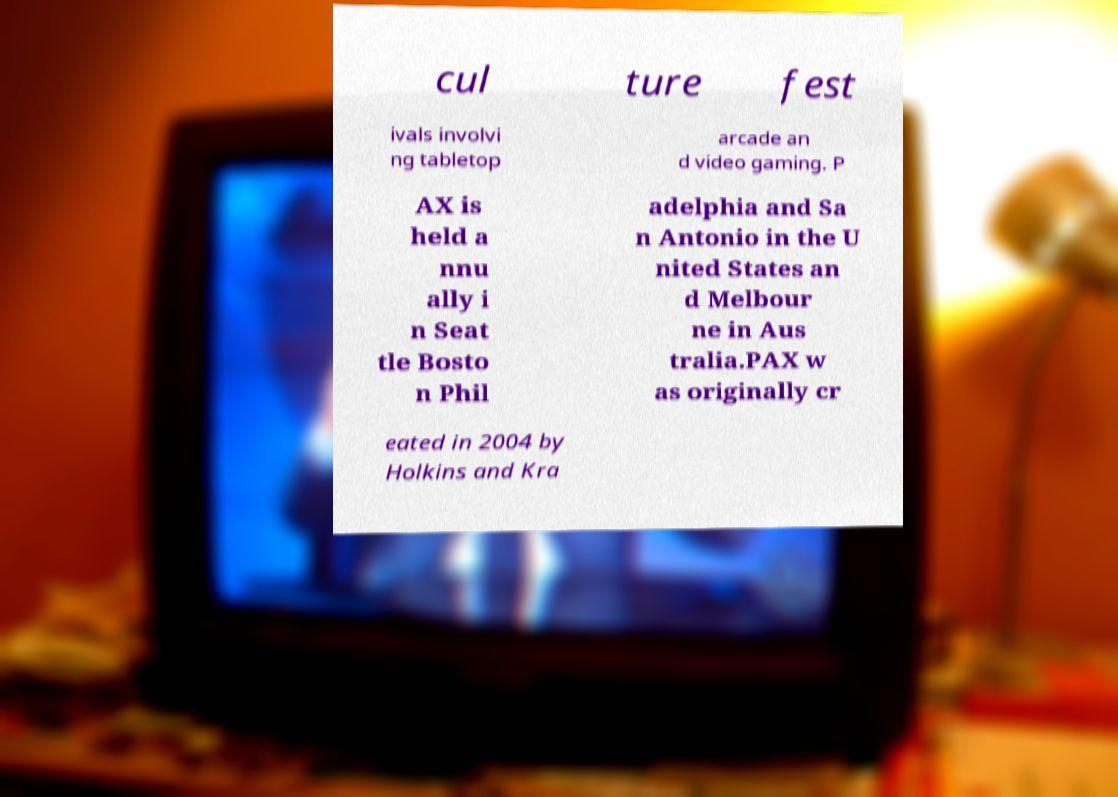Could you extract and type out the text from this image? cul ture fest ivals involvi ng tabletop arcade an d video gaming. P AX is held a nnu ally i n Seat tle Bosto n Phil adelphia and Sa n Antonio in the U nited States an d Melbour ne in Aus tralia.PAX w as originally cr eated in 2004 by Holkins and Kra 